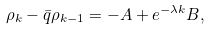<formula> <loc_0><loc_0><loc_500><loc_500>\rho _ { k } - \bar { q } \rho _ { k - 1 } = - A + e ^ { - \lambda k } B ,</formula> 